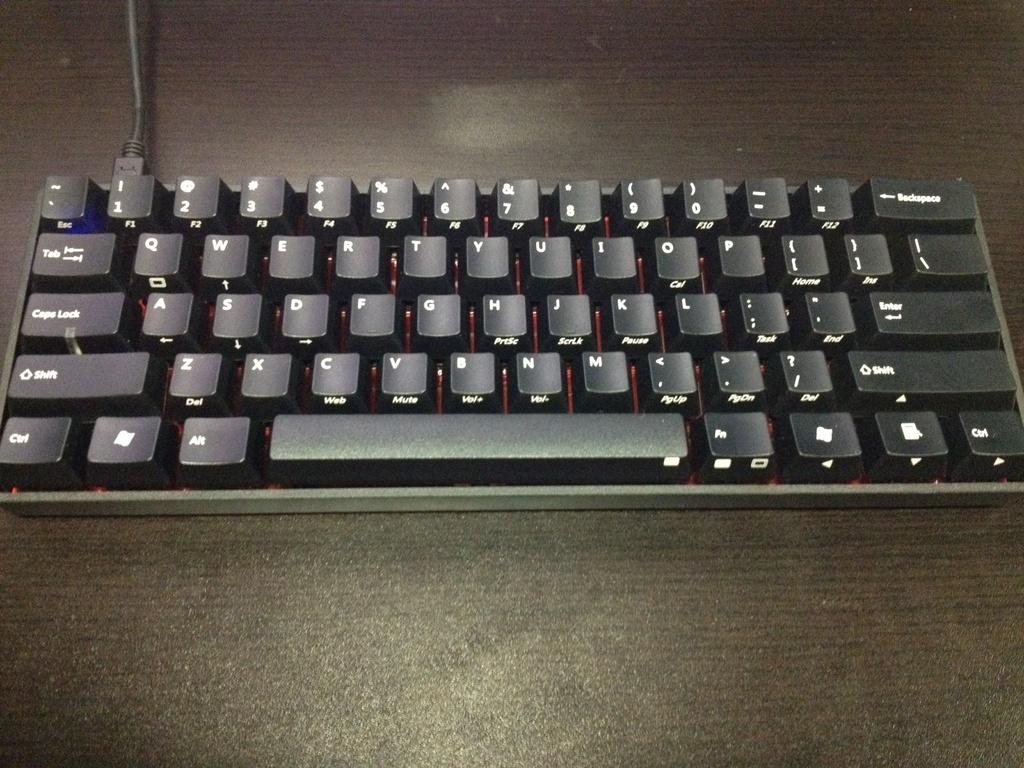What type of electronic device is visible in the image? There is a black color keyboard in the image. Can you describe any other object that is connected to the keyboard? Yes, there is a wire in the image. What type of jewel is being negotiated in the image? There is no jewel or negotiation present in the image; it features a black color keyboard and a wire. What country's flag is being displayed on the keyboard in the image? The image does not show any country's flag or any indication of a specific country. 